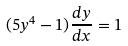<formula> <loc_0><loc_0><loc_500><loc_500>( 5 y ^ { 4 } - 1 ) \frac { d y } { d x } = 1</formula> 